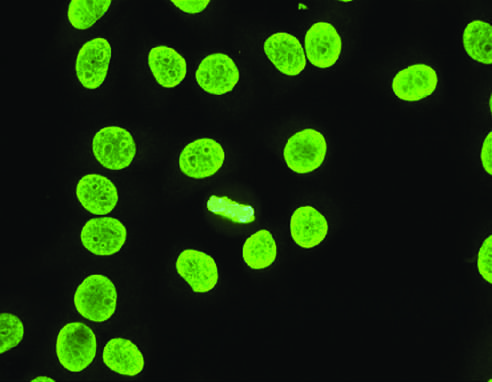re small intestine stem cells typical of antibodies reactive with dsdna, nucleosomes, and histones, and is common in sle?
Answer the question using a single word or phrase. No 